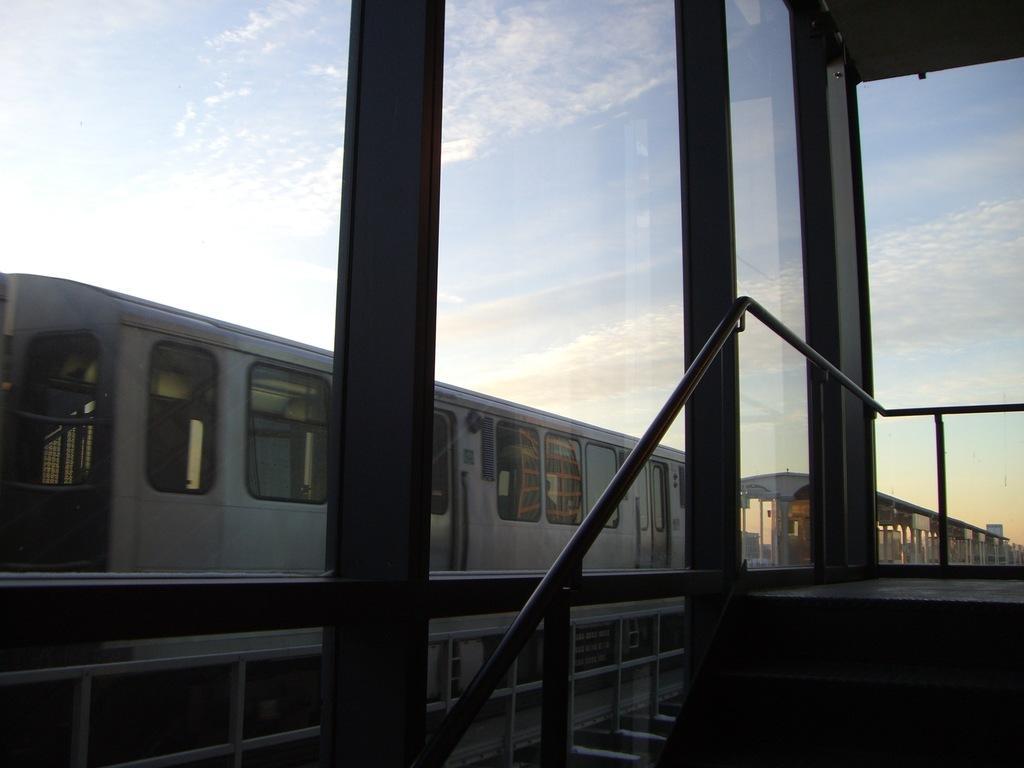Can you describe this image briefly? Outdoor picture. Sky is cloudy and it is in blue color. Train is in silver color with windows and doors. A rod in black color. 